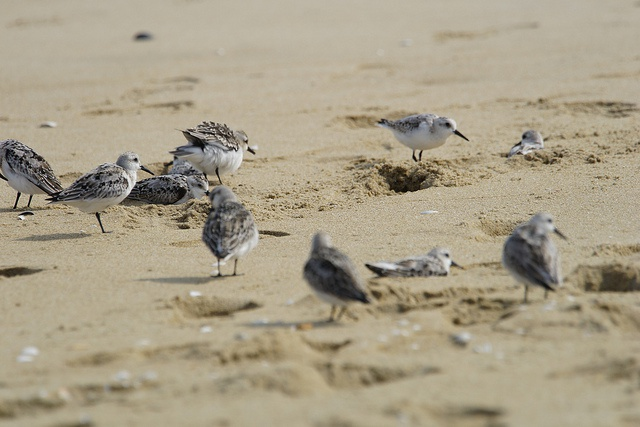Describe the objects in this image and their specific colors. I can see bird in darkgray, gray, and black tones, bird in darkgray, black, and gray tones, bird in darkgray, gray, and black tones, bird in darkgray, gray, and black tones, and bird in darkgray, gray, and black tones in this image. 